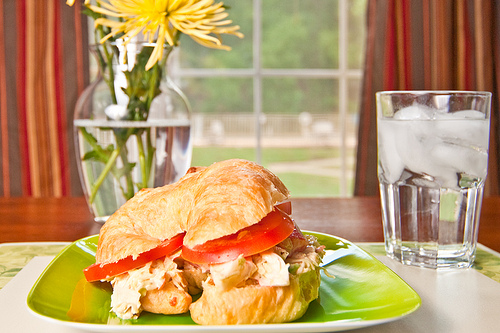Create an artistic description for a painting inspired by this image. This captivating painting captures a serene morning scene set at a rustic wooden table by a sunlit window. Vibrant yellow flowers rise elegantly from a clear glass vase, their petals catching the gentle glow of dawn. A golden-brown croissant sandwich, with succulent chicken and fresh slices of tomato, rests invitingly on a vivid green plate. Beside it, a perfectly detailed glass of ice water gleams, each ice cube catching the light in a dance of reflections. The background, softly blurred, suggests a peaceful garden just beyond the window, as the early light filters in, creating a tranquil and heartwarming atmosphere. It's a still life that exudes comfort, warmth, and the simple joys of a peaceful morning. 